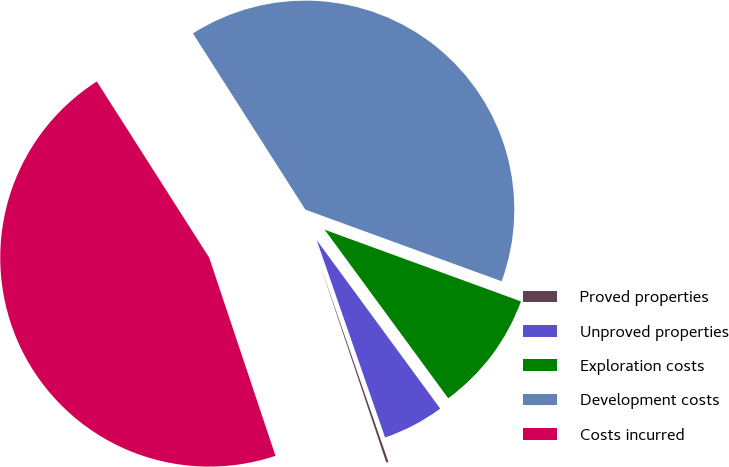Convert chart to OTSL. <chart><loc_0><loc_0><loc_500><loc_500><pie_chart><fcel>Proved properties<fcel>Unproved properties<fcel>Exploration costs<fcel>Development costs<fcel>Costs incurred<nl><fcel>0.17%<fcel>4.76%<fcel>9.36%<fcel>39.61%<fcel>46.1%<nl></chart> 